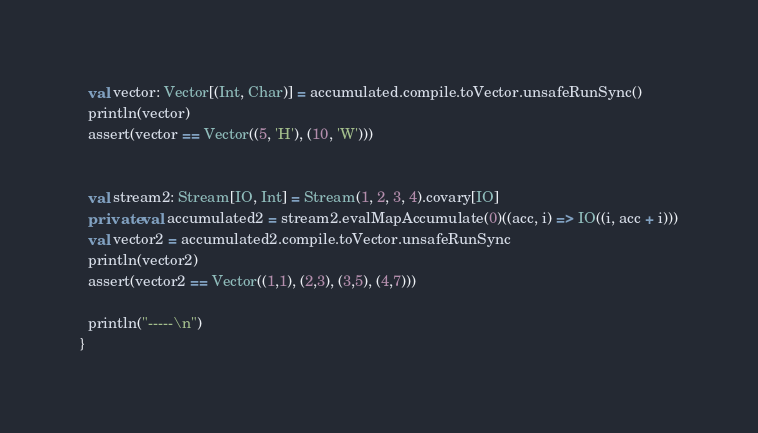Convert code to text. <code><loc_0><loc_0><loc_500><loc_500><_Scala_>  val vector: Vector[(Int, Char)] = accumulated.compile.toVector.unsafeRunSync()
  println(vector)
  assert(vector == Vector((5, 'H'), (10, 'W')))


  val stream2: Stream[IO, Int] = Stream(1, 2, 3, 4).covary[IO]
  private val accumulated2 = stream2.evalMapAccumulate(0)((acc, i) => IO((i, acc + i)))
  val vector2 = accumulated2.compile.toVector.unsafeRunSync
  println(vector2)
  assert(vector2 == Vector((1,1), (2,3), (3,5), (4,7)))

  println("-----\n")
}
</code> 